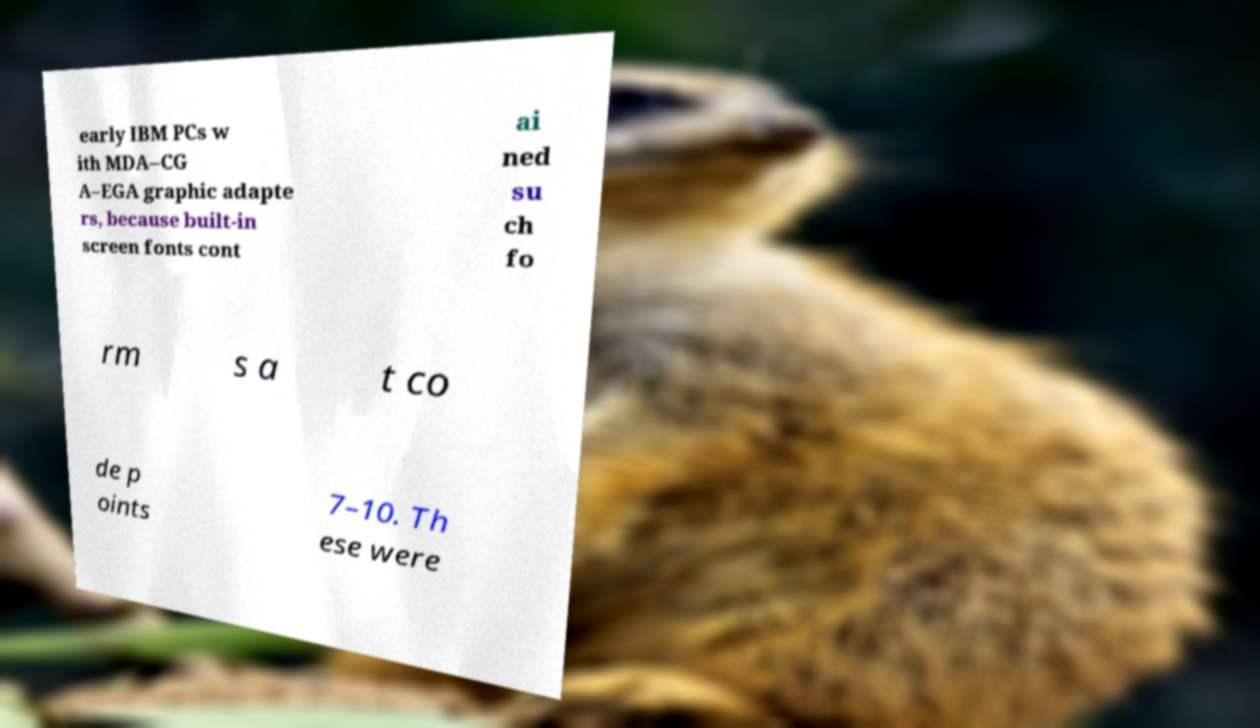Please read and relay the text visible in this image. What does it say? early IBM PCs w ith MDA–CG A–EGA graphic adapte rs, because built-in screen fonts cont ai ned su ch fo rm s a t co de p oints 7–10. Th ese were 